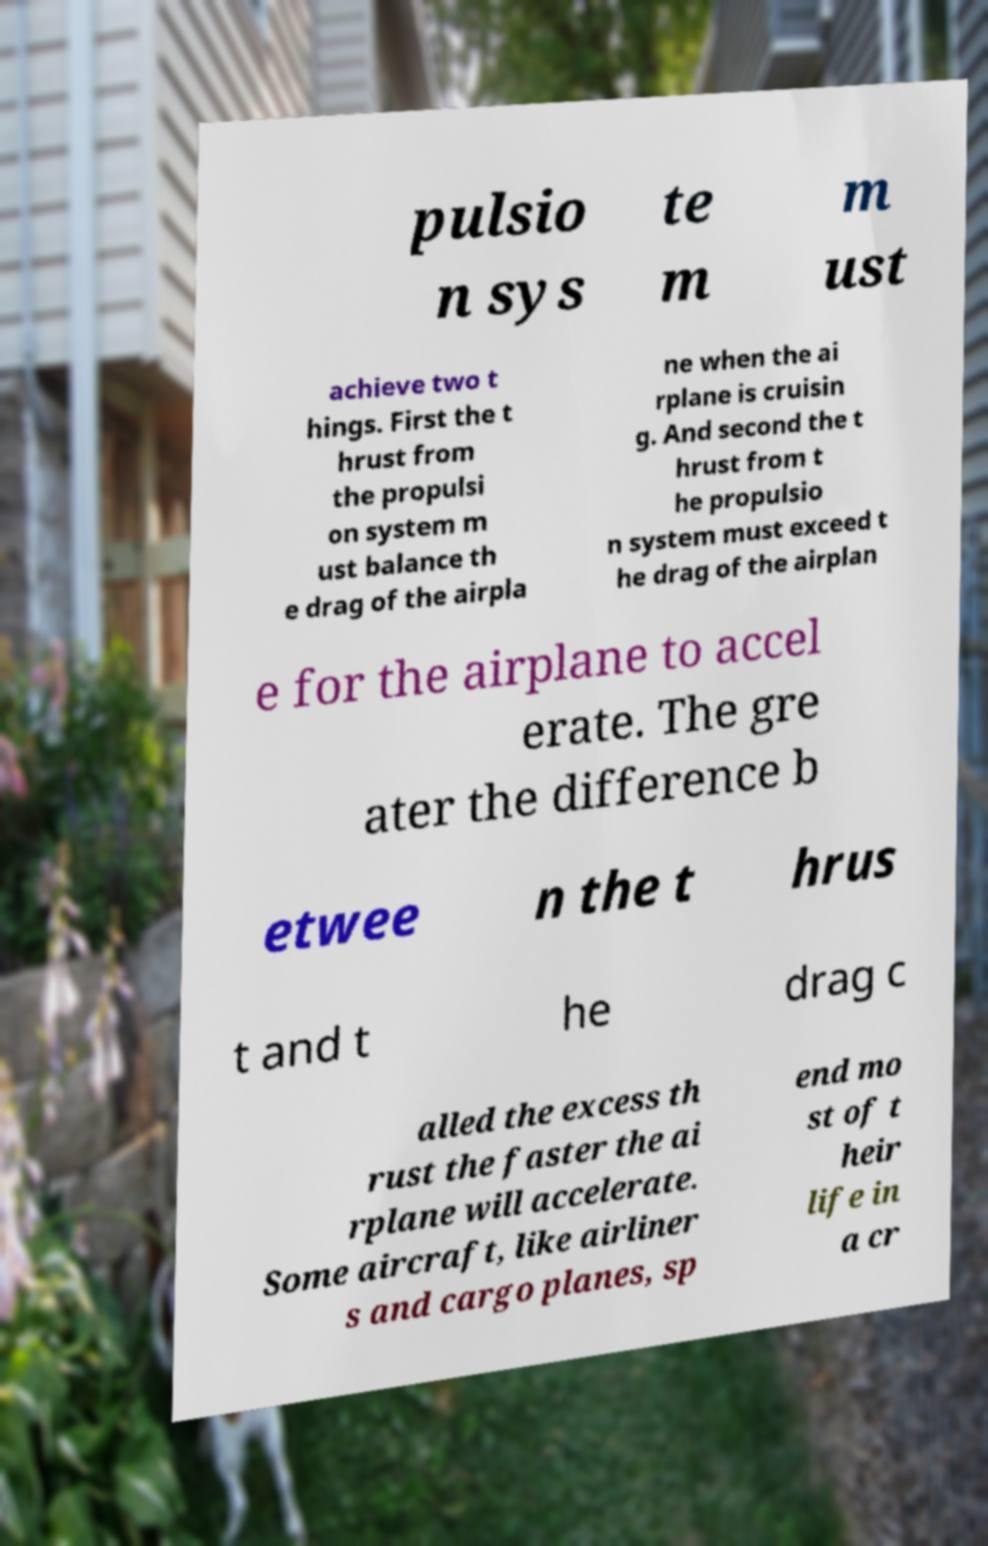Could you assist in decoding the text presented in this image and type it out clearly? pulsio n sys te m m ust achieve two t hings. First the t hrust from the propulsi on system m ust balance th e drag of the airpla ne when the ai rplane is cruisin g. And second the t hrust from t he propulsio n system must exceed t he drag of the airplan e for the airplane to accel erate. The gre ater the difference b etwee n the t hrus t and t he drag c alled the excess th rust the faster the ai rplane will accelerate. Some aircraft, like airliner s and cargo planes, sp end mo st of t heir life in a cr 